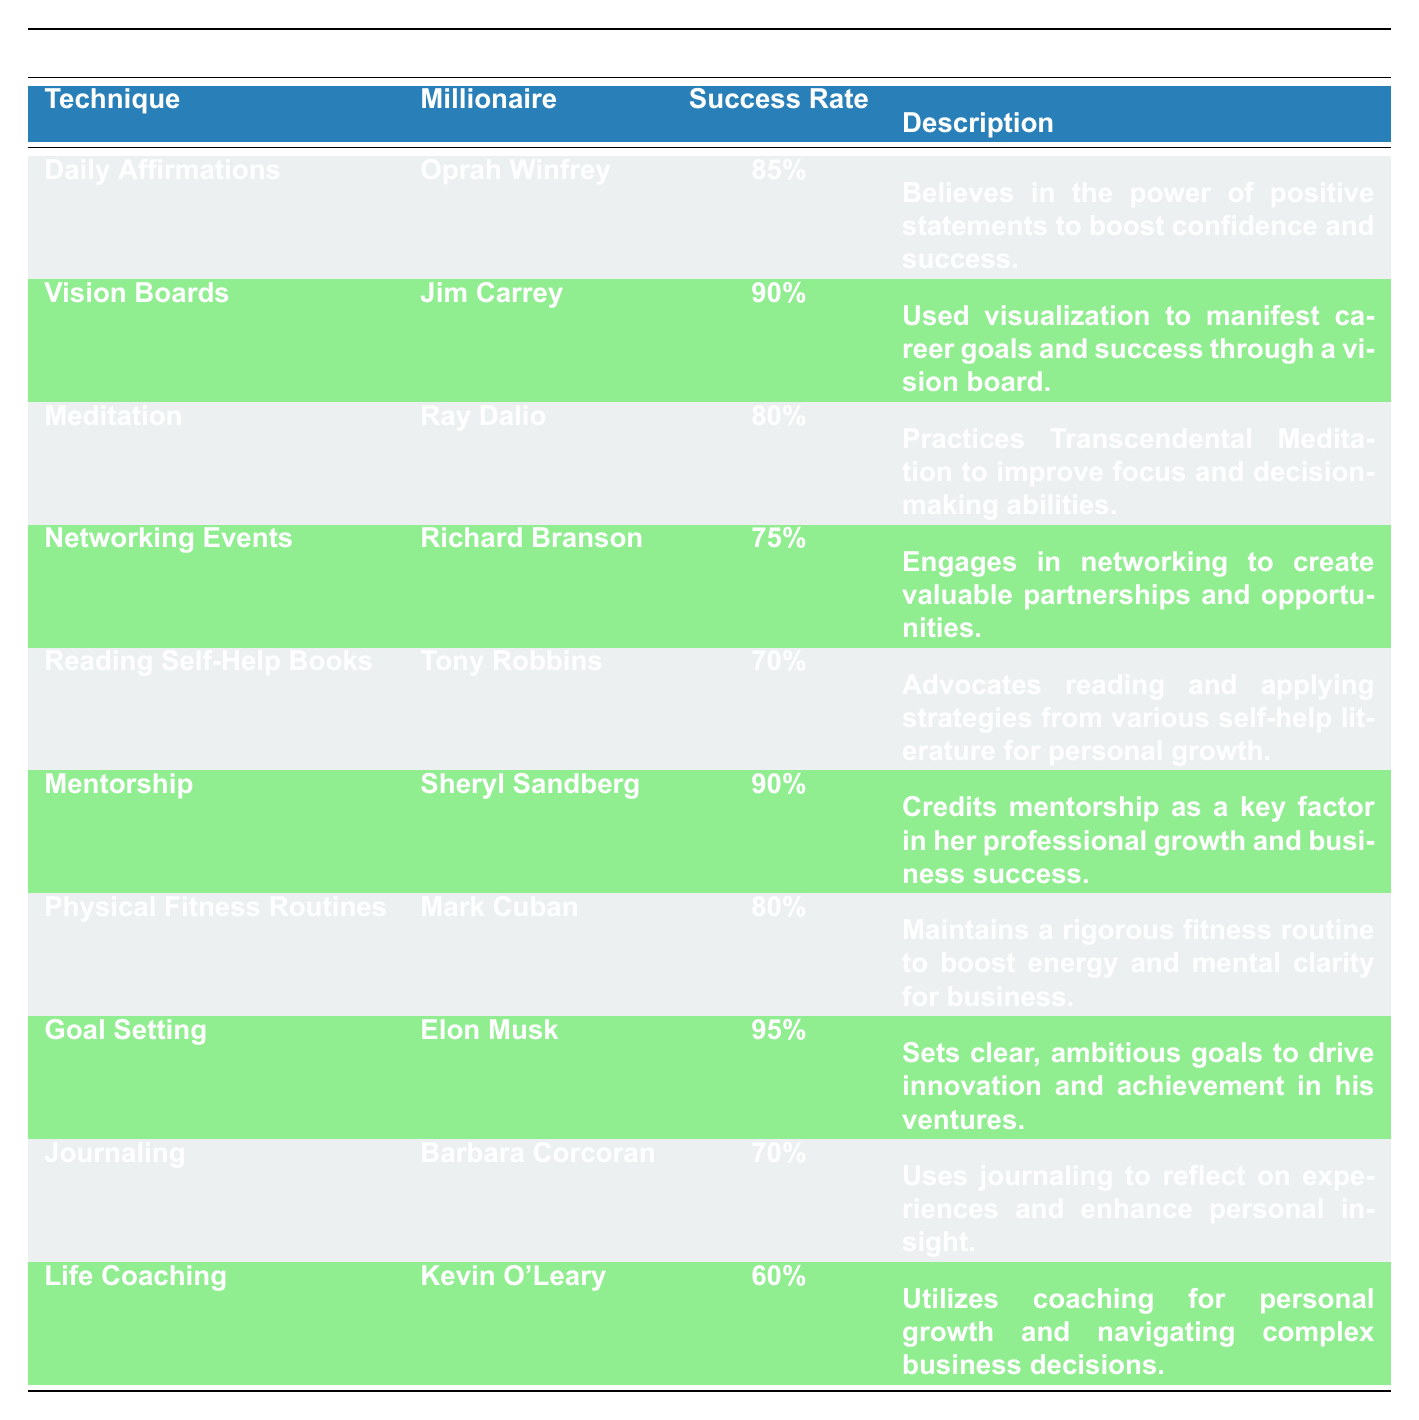What is the success rate of Daily Affirmations? The table shows that Oprah Winfrey uses Daily Affirmations and it has a success rate of 85%.
Answer: 85% Which personal development technique has the highest success rate? According to the table, Goal Setting, used by Elon Musk, has the highest success rate of 95%.
Answer: 95% Who uses Vision Boards and what is their success rate? Jim Carrey uses Vision Boards and his success rate is 90%, as indicated in the table.
Answer: Jim Carrey, 90% Is the success rate of Life Coaching greater than 70%? The table states that the success rate of Life Coaching, used by Kevin O'Leary, is 60%, which is not greater than 70%.
Answer: No What is the average success rate of the techniques listed in the table? To find the average, add all the success rates: (85 + 90 + 80 + 75 + 70 + 90 + 80 + 95 + 70 + 60) = 795. Then divide by the number of techniques (10). The average is 795 / 10 = 79.5%.
Answer: 79.5% Which millionaire attributes their success to Mentorship? The table indicates that Sheryl Sandberg credits her success to Mentorship.
Answer: Sheryl Sandberg Are Meditation and Physical Fitness Routines used by millionaires with a success rate of at least 80%? The table shows Ray Dalio, using Meditation, has a success rate of 80%, and Mark Cuban, with Physical Fitness Routines, also has a success rate of 80%. Therefore, both have rates at least 80%.
Answer: Yes Which technique has a lower success rate: Reading Self-Help Books or Networking Events? Tony Robbins’ Reading Self-Help Books has a success rate of 70%, while Richard Branson’s Networking Events has a success rate of 75%. Since 70% is less than 75%, Reading Self-Help Books has a lower success rate.
Answer: Reading Self-Help Books What percentage of millionaires mentioned Physical Fitness Routines and Daily Affirmations? Physical Fitness Routines is attributed to Mark Cuban with a success rate of 80%, and Daily Affirmations is attributed to Oprah Winfrey with a success rate of 85%. The table indicates that these two techniques were mentioned by two different millionaires.
Answer: 2 techniques 